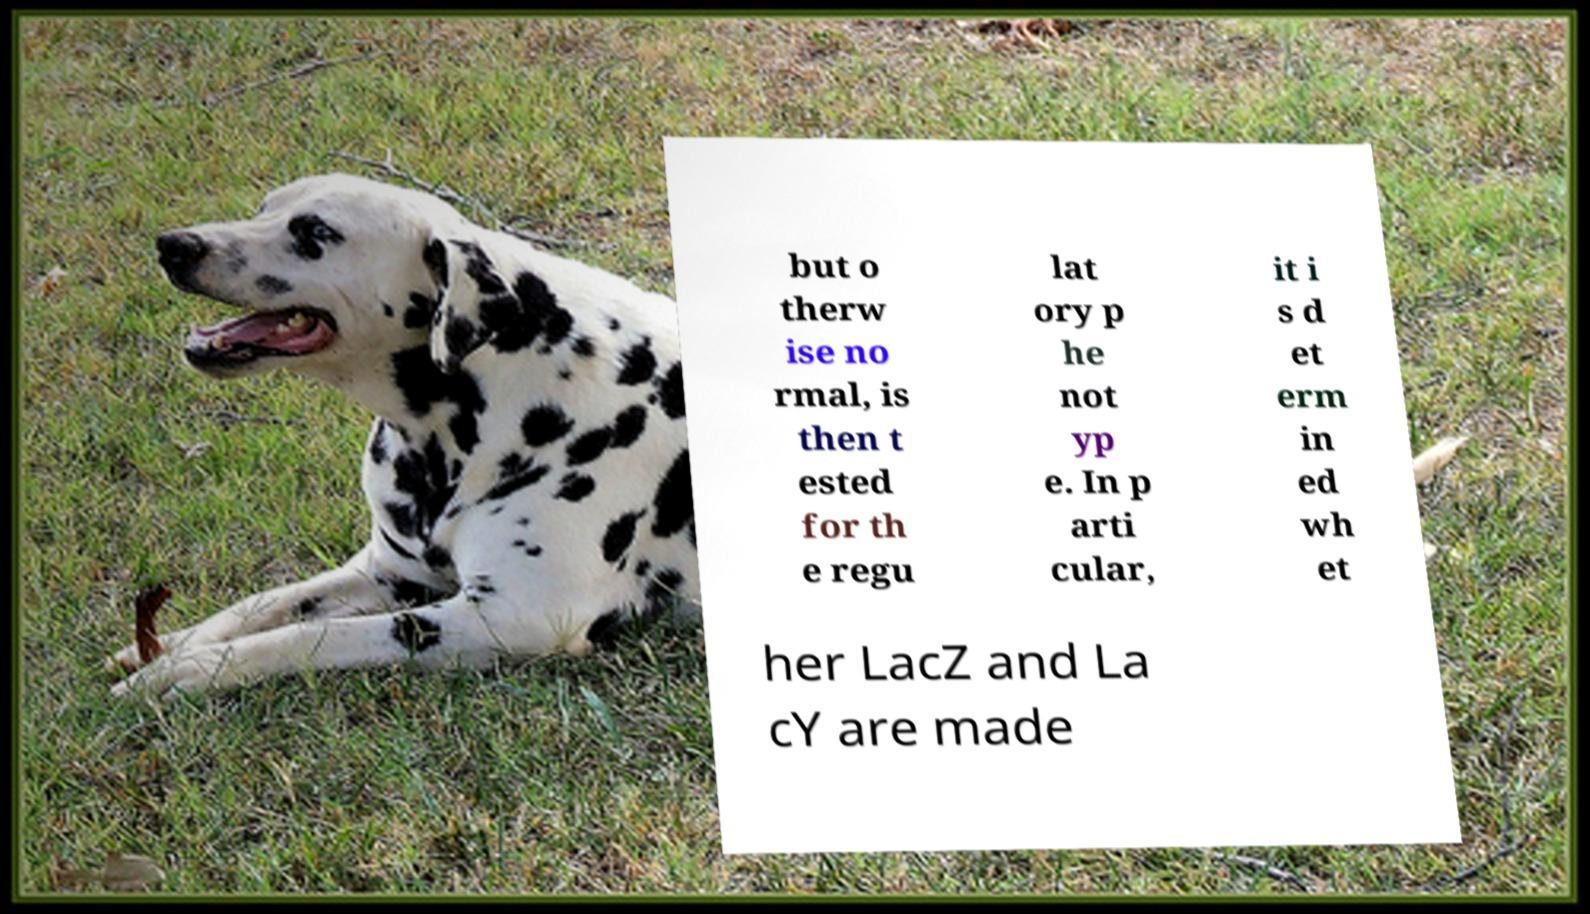Could you assist in decoding the text presented in this image and type it out clearly? but o therw ise no rmal, is then t ested for th e regu lat ory p he not yp e. In p arti cular, it i s d et erm in ed wh et her LacZ and La cY are made 